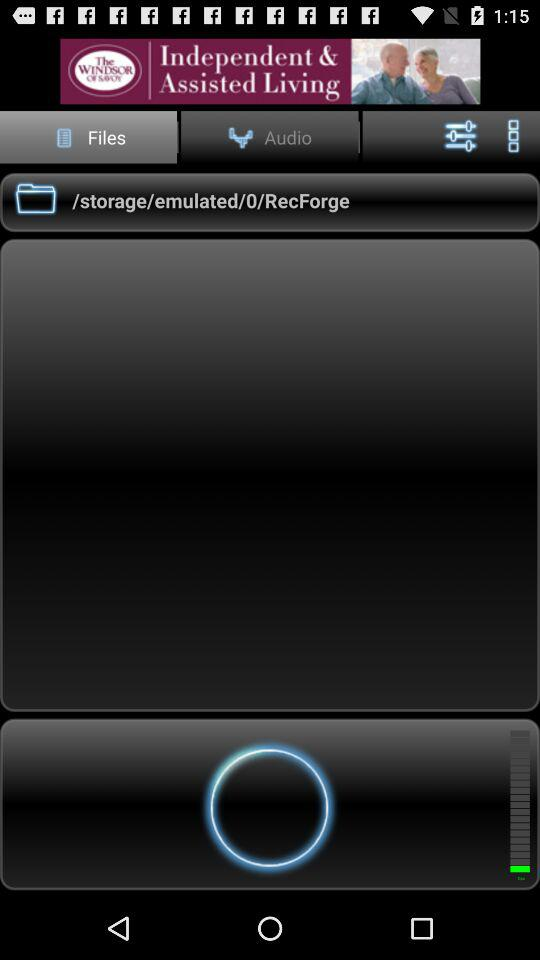What tab is currently selected? The selected tab is "Files". 